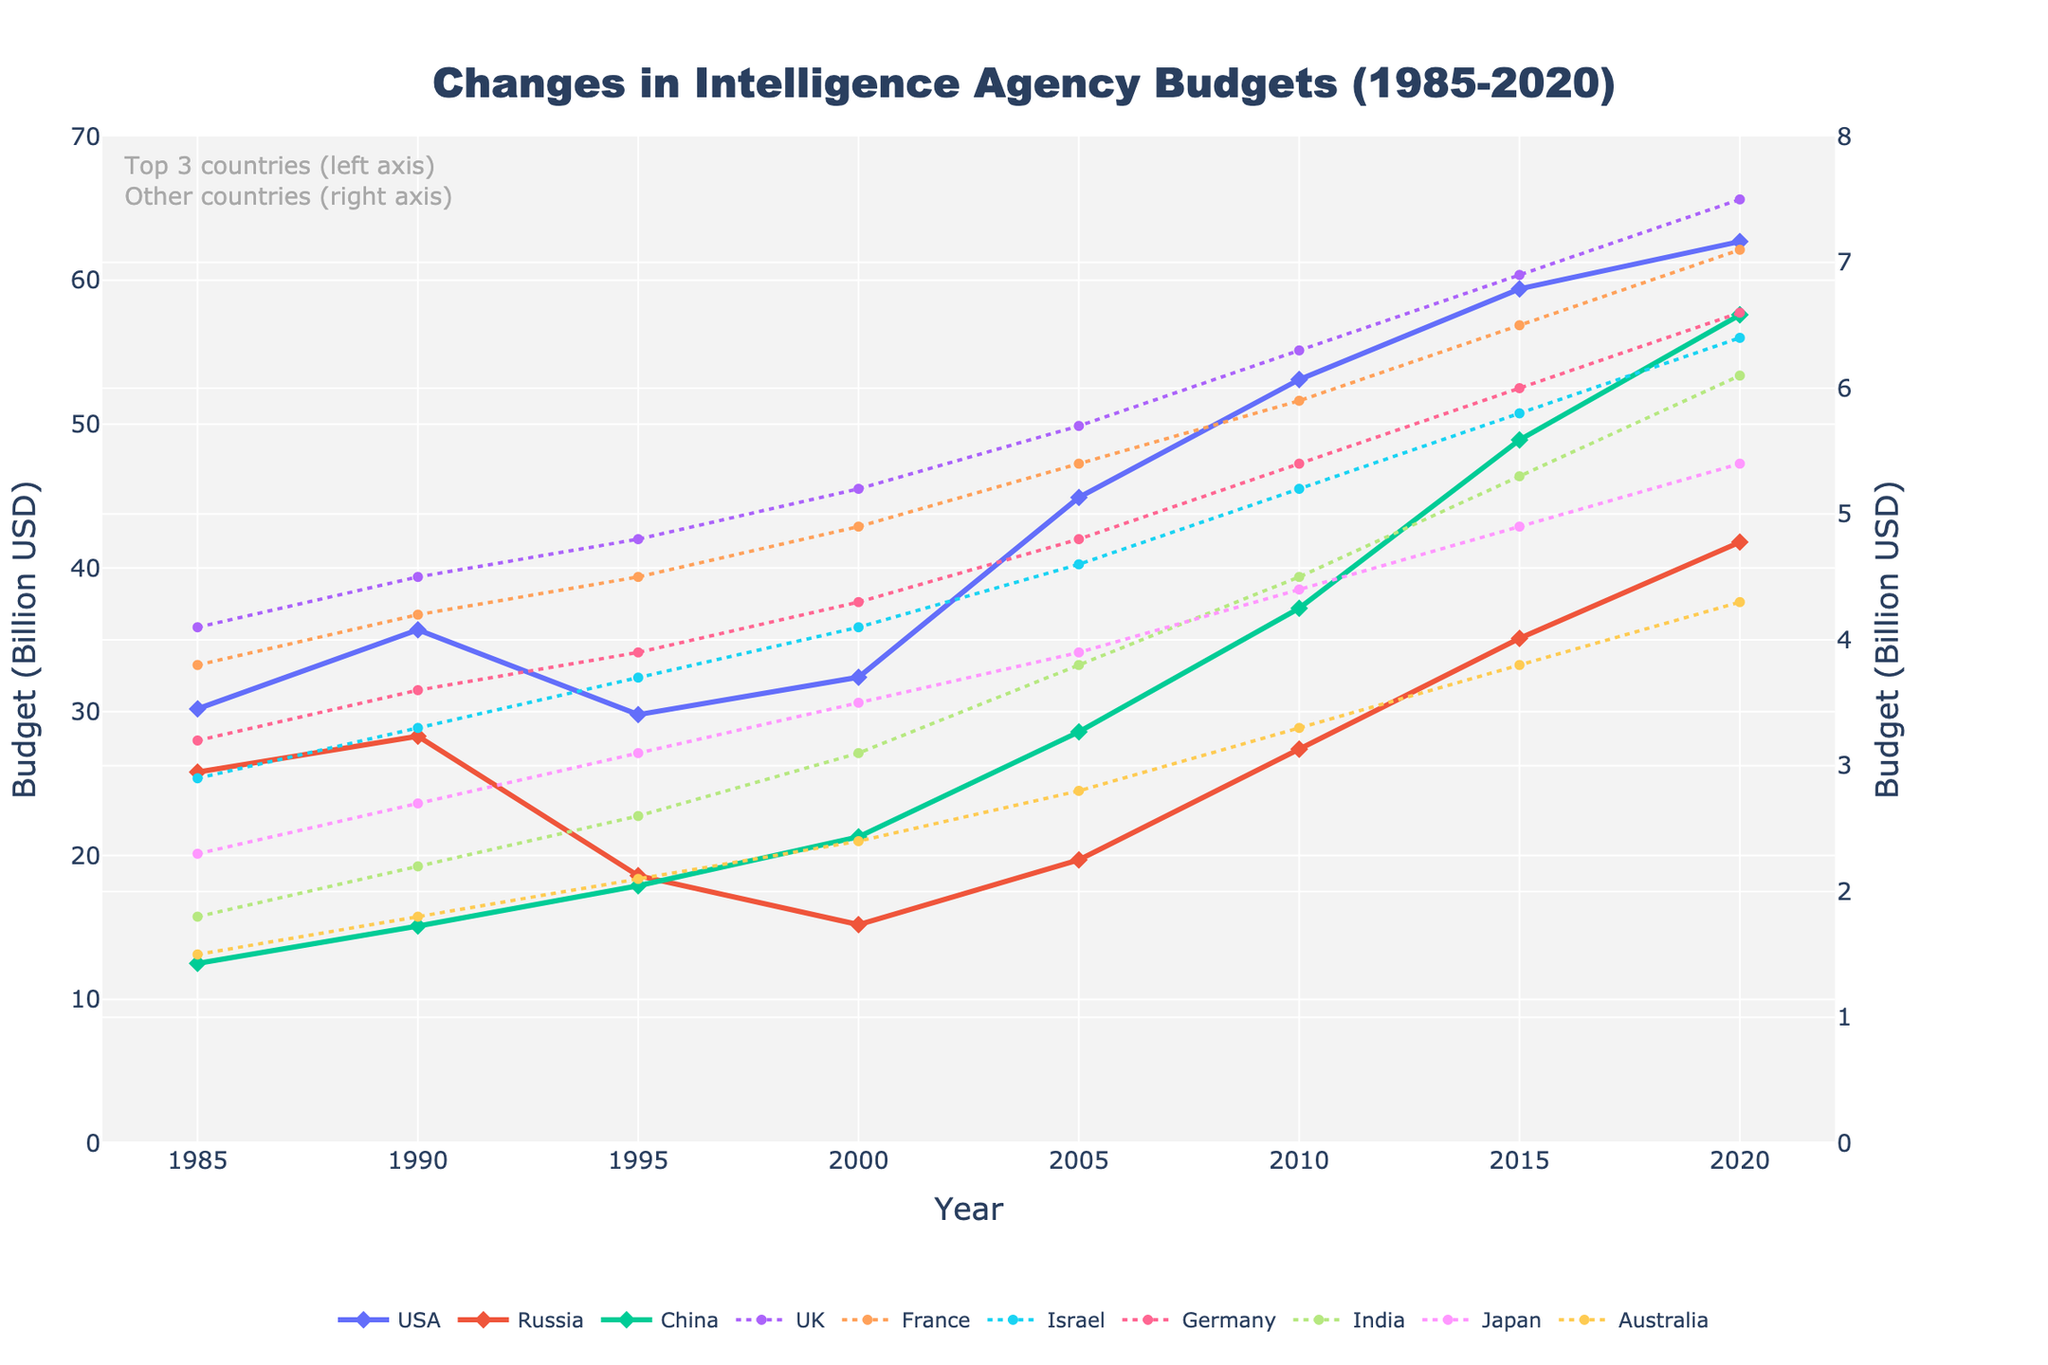What's the difference between the USA's budget in 2020 and Russia’s budget in 2020? To find the difference, subtract Russia's 2020 budget (41.8) from the USA's 2020 budget (62.7). 62.7 - 41.8 = 20.9
Answer: 20.9 Which country had the highest budget in 2010? Look at the budgets for all countries in 2010 and identify the highest value. In 2010, USA has the highest budget of 53.1 billion USD.
Answer: USA How many years did China's budget increase compared to the previous year? Compare each year’s budget for China to the previous year. The years where the budget increased are: 2000 (vs 1995), 2005 (vs 2000), 2010 (vs 2005), 2015 (vs 2010), and 2020 (vs 2015). So, there are 5 such years.
Answer: 5 Is France's budget in 1995 greater than or less than Germany's budget in 1995? Compare the budgets for France (4.5) and Germany (3.9) in 1995. France's budget is greater.
Answer: Greater What’s the average budget for Israel from 2000 to 2020? Add Israel's budgets from 2000 (4.1), 2005 (4.6), 2010 (5.2), 2015 (5.8), and 2020 (6.4). Divide the sum by the number of years. The sum is 26.1 and the average is 26.1 / 5 = 5.22
Answer: 5.22 What is the trend of Japan's budget over the years? Look at Japan's budgets from 1985 to 2020: 2.3, 2.7, 3.1, 3.5, 3.9, 4.4, 4.9, 5.4. The trend shows a steady increase in Japan’s budget over the years.
Answer: Increasing In what year did India’s budget first exceed 4 billion USD? Look at India's budgets and identify the first year it exceeds 4 billion USD. India's budget first exceeded 4 billion USD in 2010 with a value of 4.5.
Answer: 2010 Describe the visual difference in the plot lines for the top 3 countries (USA, Russia, China) compared to the other countries. The top 3 countries have thicker lines with markers in diamond shapes, and the rest have thinner, dashed lines with circle markers.
Answer: Thicker, solid lines with diamond markers vs thinner, dashed lines with circle markers Which country had the smallest budget increase between 1990 and 2020? Calculate the budget increase for each country from 1990 to 2020 and find the smallest increment. India's budget increased from 2.2 to 6.1, which is an increase of 3.9 billion; this is the smallest among others.
Answer: India 